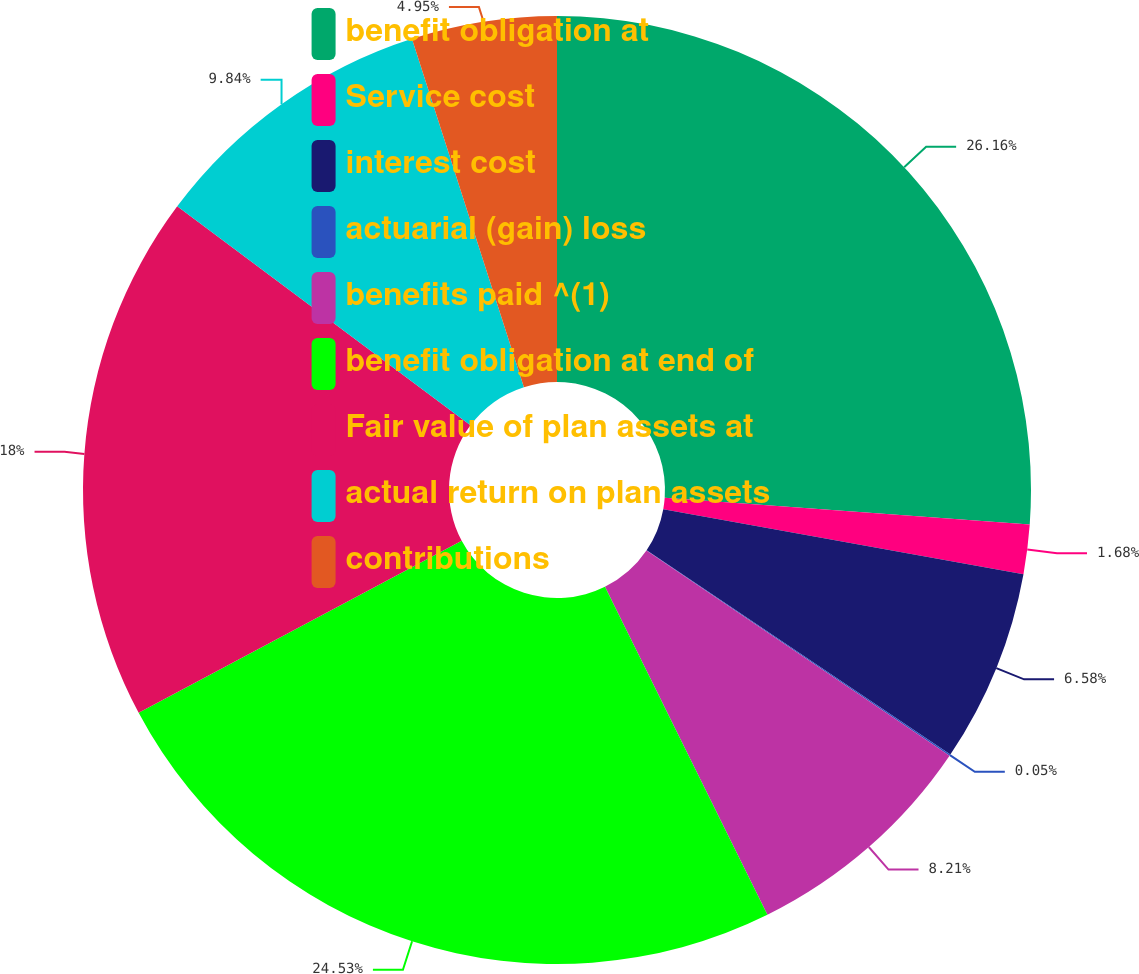Convert chart to OTSL. <chart><loc_0><loc_0><loc_500><loc_500><pie_chart><fcel>benefit obligation at<fcel>Service cost<fcel>interest cost<fcel>actuarial (gain) loss<fcel>benefits paid ^(1)<fcel>benefit obligation at end of<fcel>Fair value of plan assets at<fcel>actual return on plan assets<fcel>contributions<nl><fcel>26.16%<fcel>1.68%<fcel>6.58%<fcel>0.05%<fcel>8.21%<fcel>24.53%<fcel>18.0%<fcel>9.84%<fcel>4.95%<nl></chart> 